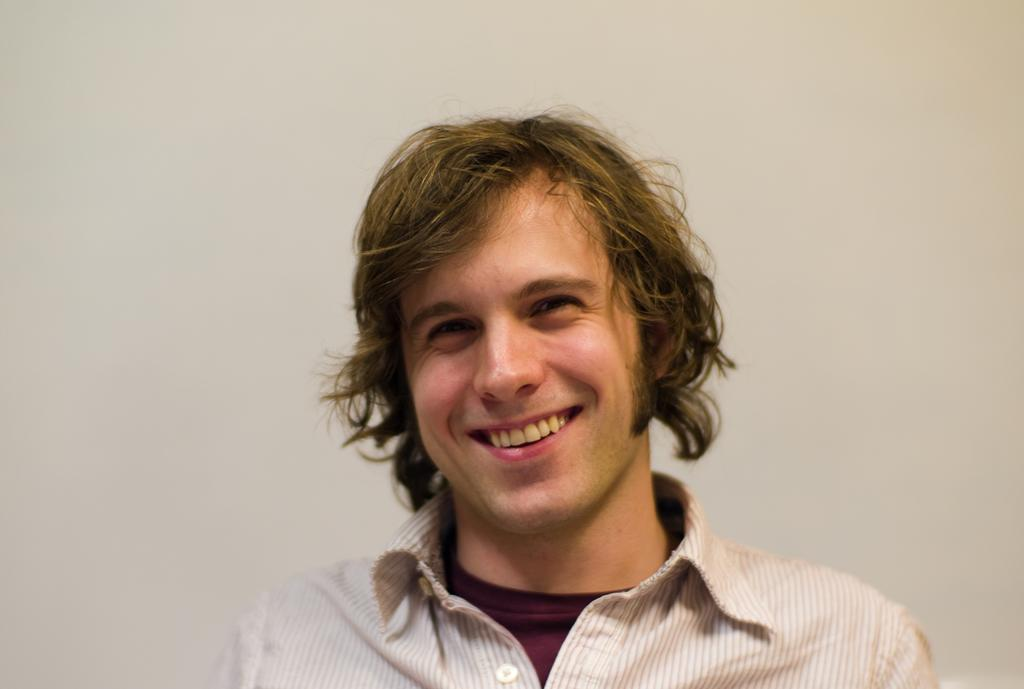Who or what is the main subject in the image? There is a person in the center of the image. What is the person doing in the image? The person is smiling. What can be seen in the background of the image? There is a wall in the background of the image. What type of button can be seen on the person's toe in the image? There is no button visible on the person's toe in the image. What type of beef is being cooked in the background of the image? There is no beef or cooking activity present in the image; it only features a person and a wall in the background. 